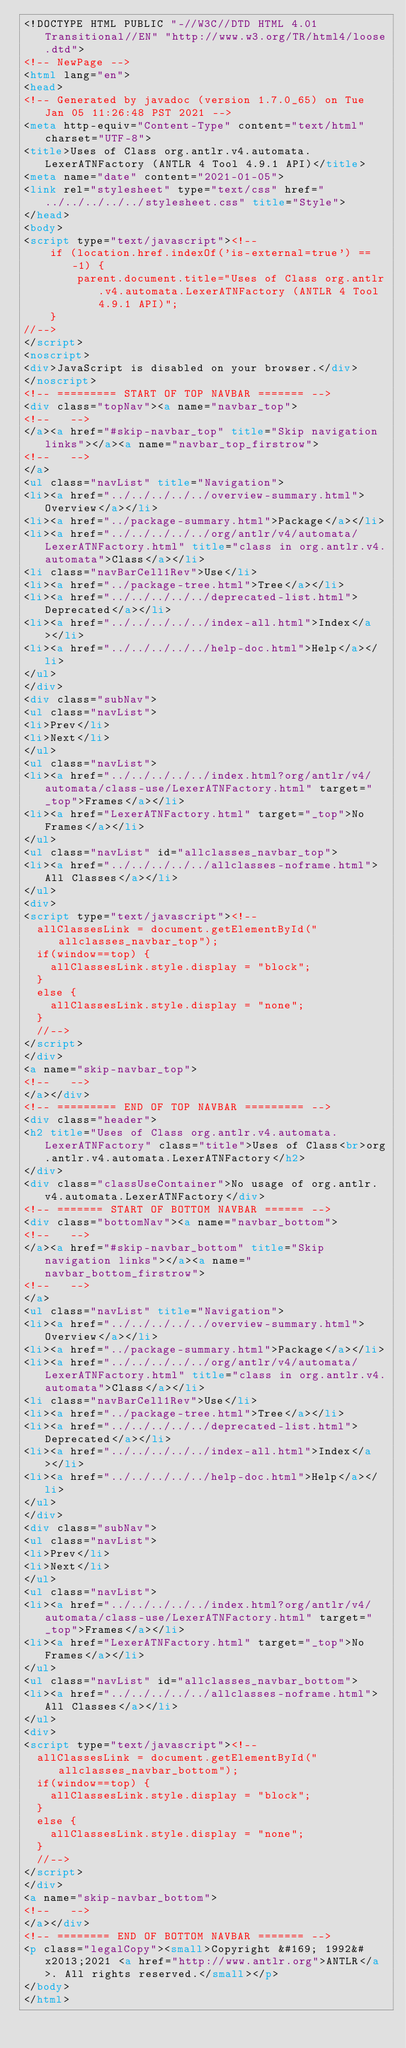<code> <loc_0><loc_0><loc_500><loc_500><_HTML_><!DOCTYPE HTML PUBLIC "-//W3C//DTD HTML 4.01 Transitional//EN" "http://www.w3.org/TR/html4/loose.dtd">
<!-- NewPage -->
<html lang="en">
<head>
<!-- Generated by javadoc (version 1.7.0_65) on Tue Jan 05 11:26:48 PST 2021 -->
<meta http-equiv="Content-Type" content="text/html" charset="UTF-8">
<title>Uses of Class org.antlr.v4.automata.LexerATNFactory (ANTLR 4 Tool 4.9.1 API)</title>
<meta name="date" content="2021-01-05">
<link rel="stylesheet" type="text/css" href="../../../../../stylesheet.css" title="Style">
</head>
<body>
<script type="text/javascript"><!--
    if (location.href.indexOf('is-external=true') == -1) {
        parent.document.title="Uses of Class org.antlr.v4.automata.LexerATNFactory (ANTLR 4 Tool 4.9.1 API)";
    }
//-->
</script>
<noscript>
<div>JavaScript is disabled on your browser.</div>
</noscript>
<!-- ========= START OF TOP NAVBAR ======= -->
<div class="topNav"><a name="navbar_top">
<!--   -->
</a><a href="#skip-navbar_top" title="Skip navigation links"></a><a name="navbar_top_firstrow">
<!--   -->
</a>
<ul class="navList" title="Navigation">
<li><a href="../../../../../overview-summary.html">Overview</a></li>
<li><a href="../package-summary.html">Package</a></li>
<li><a href="../../../../../org/antlr/v4/automata/LexerATNFactory.html" title="class in org.antlr.v4.automata">Class</a></li>
<li class="navBarCell1Rev">Use</li>
<li><a href="../package-tree.html">Tree</a></li>
<li><a href="../../../../../deprecated-list.html">Deprecated</a></li>
<li><a href="../../../../../index-all.html">Index</a></li>
<li><a href="../../../../../help-doc.html">Help</a></li>
</ul>
</div>
<div class="subNav">
<ul class="navList">
<li>Prev</li>
<li>Next</li>
</ul>
<ul class="navList">
<li><a href="../../../../../index.html?org/antlr/v4/automata/class-use/LexerATNFactory.html" target="_top">Frames</a></li>
<li><a href="LexerATNFactory.html" target="_top">No Frames</a></li>
</ul>
<ul class="navList" id="allclasses_navbar_top">
<li><a href="../../../../../allclasses-noframe.html">All Classes</a></li>
</ul>
<div>
<script type="text/javascript"><!--
  allClassesLink = document.getElementById("allclasses_navbar_top");
  if(window==top) {
    allClassesLink.style.display = "block";
  }
  else {
    allClassesLink.style.display = "none";
  }
  //-->
</script>
</div>
<a name="skip-navbar_top">
<!--   -->
</a></div>
<!-- ========= END OF TOP NAVBAR ========= -->
<div class="header">
<h2 title="Uses of Class org.antlr.v4.automata.LexerATNFactory" class="title">Uses of Class<br>org.antlr.v4.automata.LexerATNFactory</h2>
</div>
<div class="classUseContainer">No usage of org.antlr.v4.automata.LexerATNFactory</div>
<!-- ======= START OF BOTTOM NAVBAR ====== -->
<div class="bottomNav"><a name="navbar_bottom">
<!--   -->
</a><a href="#skip-navbar_bottom" title="Skip navigation links"></a><a name="navbar_bottom_firstrow">
<!--   -->
</a>
<ul class="navList" title="Navigation">
<li><a href="../../../../../overview-summary.html">Overview</a></li>
<li><a href="../package-summary.html">Package</a></li>
<li><a href="../../../../../org/antlr/v4/automata/LexerATNFactory.html" title="class in org.antlr.v4.automata">Class</a></li>
<li class="navBarCell1Rev">Use</li>
<li><a href="../package-tree.html">Tree</a></li>
<li><a href="../../../../../deprecated-list.html">Deprecated</a></li>
<li><a href="../../../../../index-all.html">Index</a></li>
<li><a href="../../../../../help-doc.html">Help</a></li>
</ul>
</div>
<div class="subNav">
<ul class="navList">
<li>Prev</li>
<li>Next</li>
</ul>
<ul class="navList">
<li><a href="../../../../../index.html?org/antlr/v4/automata/class-use/LexerATNFactory.html" target="_top">Frames</a></li>
<li><a href="LexerATNFactory.html" target="_top">No Frames</a></li>
</ul>
<ul class="navList" id="allclasses_navbar_bottom">
<li><a href="../../../../../allclasses-noframe.html">All Classes</a></li>
</ul>
<div>
<script type="text/javascript"><!--
  allClassesLink = document.getElementById("allclasses_navbar_bottom");
  if(window==top) {
    allClassesLink.style.display = "block";
  }
  else {
    allClassesLink.style.display = "none";
  }
  //-->
</script>
</div>
<a name="skip-navbar_bottom">
<!--   -->
</a></div>
<!-- ======== END OF BOTTOM NAVBAR ======= -->
<p class="legalCopy"><small>Copyright &#169; 1992&#x2013;2021 <a href="http://www.antlr.org">ANTLR</a>. All rights reserved.</small></p>
</body>
</html>
</code> 